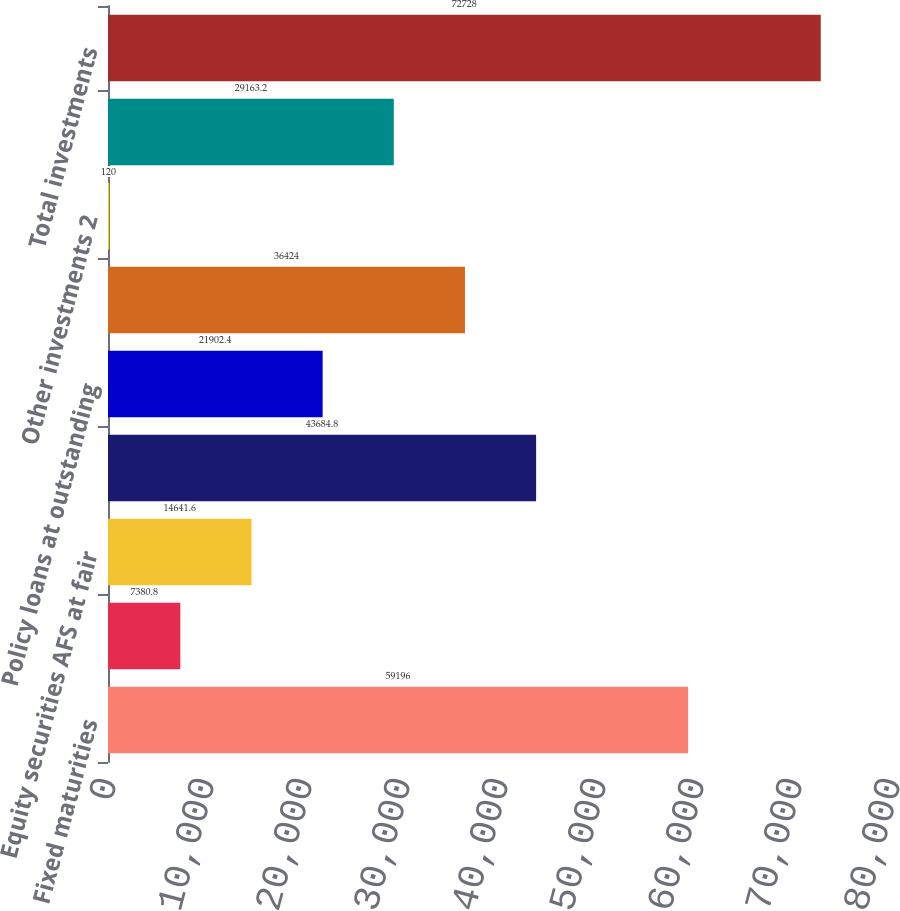Convert chart to OTSL. <chart><loc_0><loc_0><loc_500><loc_500><bar_chart><fcel>Fixed maturities<fcel>Fixed maturities at fair value<fcel>Equity securities AFS at fair<fcel>Mortgage loans<fcel>Policy loans at outstanding<fcel>Limited partnerships and other<fcel>Other investments 2<fcel>Short-term investments<fcel>Total investments<nl><fcel>59196<fcel>7380.8<fcel>14641.6<fcel>43684.8<fcel>21902.4<fcel>36424<fcel>120<fcel>29163.2<fcel>72728<nl></chart> 